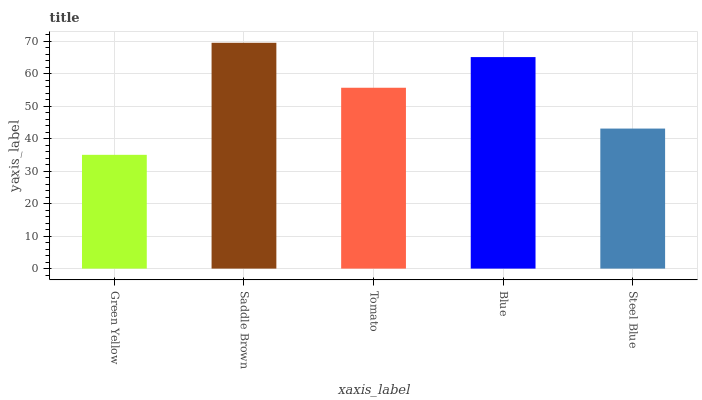Is Tomato the minimum?
Answer yes or no. No. Is Tomato the maximum?
Answer yes or no. No. Is Saddle Brown greater than Tomato?
Answer yes or no. Yes. Is Tomato less than Saddle Brown?
Answer yes or no. Yes. Is Tomato greater than Saddle Brown?
Answer yes or no. No. Is Saddle Brown less than Tomato?
Answer yes or no. No. Is Tomato the high median?
Answer yes or no. Yes. Is Tomato the low median?
Answer yes or no. Yes. Is Saddle Brown the high median?
Answer yes or no. No. Is Blue the low median?
Answer yes or no. No. 